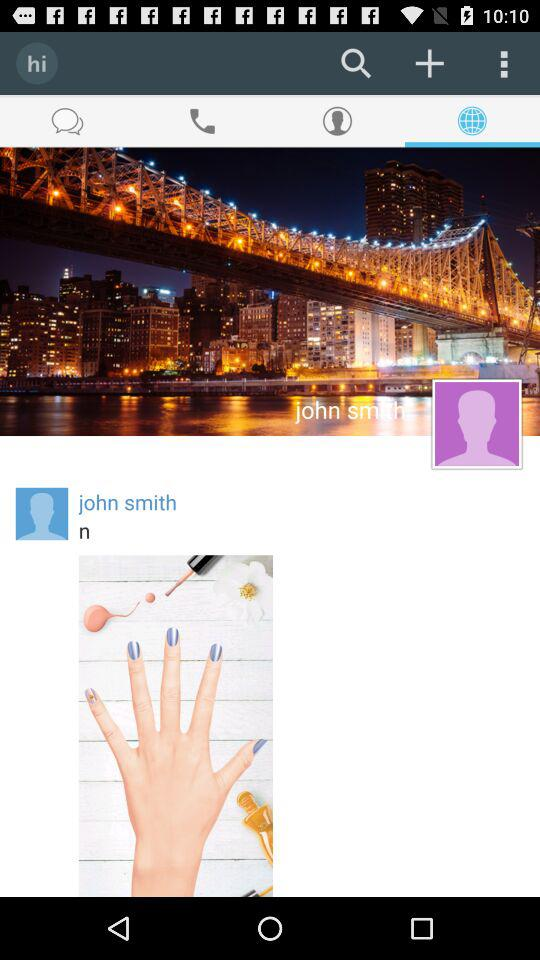What is the username? The username is "john smith". 